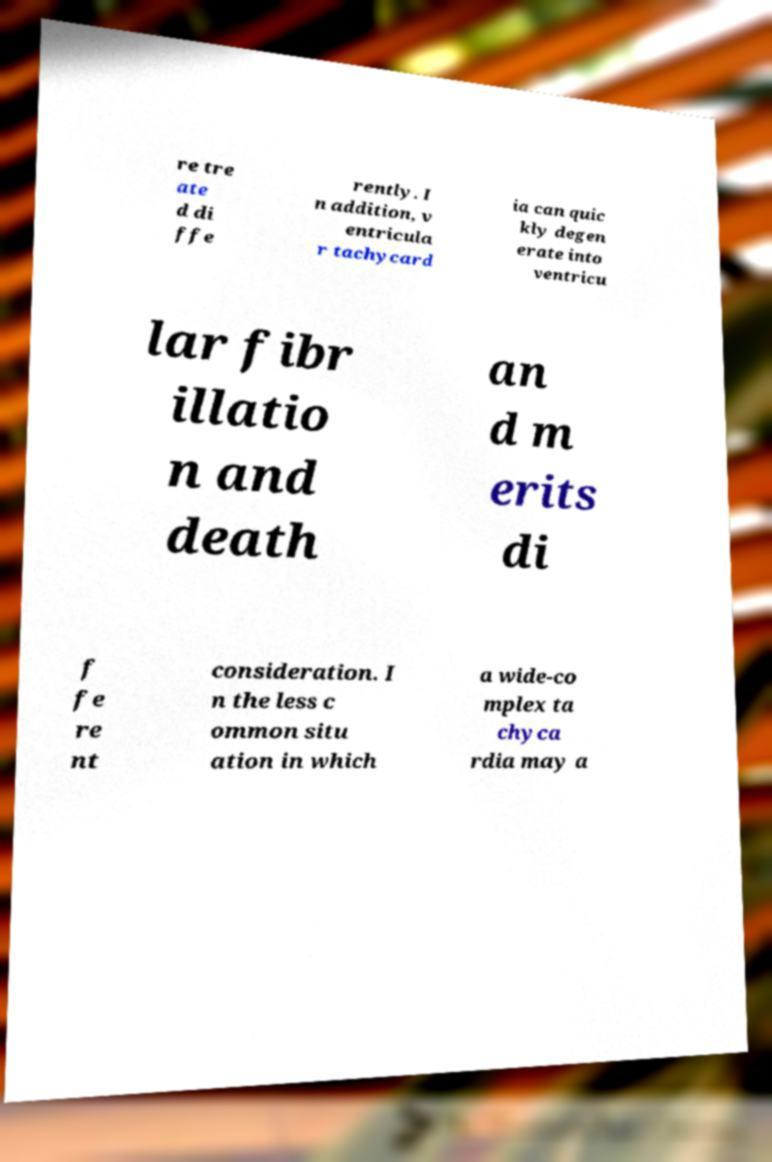For documentation purposes, I need the text within this image transcribed. Could you provide that? re tre ate d di ffe rently. I n addition, v entricula r tachycard ia can quic kly degen erate into ventricu lar fibr illatio n and death an d m erits di f fe re nt consideration. I n the less c ommon situ ation in which a wide-co mplex ta chyca rdia may a 